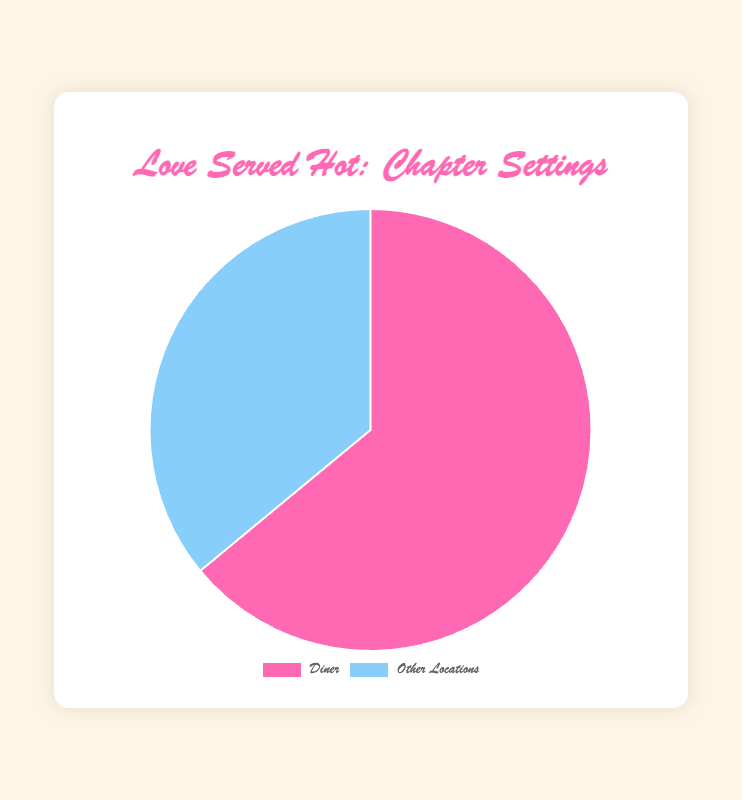what proportion of the story chapters are set in the diner? The pie chart shows 32 chapters in the diner out of a total of 50 chapters (32 + 18). Thus, the proportion is calculated as 32/50.
Answer: 64% how many more chapters are set in the diner compared to other locations? According to the pie chart, there are 32 chapters set in the diner and 18 in other locations. The difference is 32 - 18.
Answer: 14 what is the ratio of chapters set in the diner to chapters set in other locations? From the pie chart, the number of chapters set in the diner is 32, and the number set in other locations is 18. So, the ratio is 32:18. Simplified, it becomes 16:9.
Answer: 16:9 which location has more chapters set in it, and by how much? Comparing the two segments of the pie chart, the diner has 32 chapters, and other locations have 18 chapters. The diner has more chapters by the difference of 32 - 18.
Answer: diner, by 14 chapters if a chapter is chosen at random, what is the probability that it is set in the diner? There are 32 chapters set in the diner out of a total of 50 chapters (32 + 18). The probability is calculated as 32/50.
Answer: 0.64 how does the proportion of chapters set in the diner compare to those set in other locations? From the pie chart, we see the diner has 32 chapters and other locations have 18 chapters out of a total of 50 chapters. The proportion for diner is 32/50 (64%) and for other locations is 18/50 (36%).
Answer: 64% vs. 36% what is the visual difference in the pie chart sections representing the diner and other locations? The pie chart shows the section for the diner in pink and other locations in light blue. The pink section representing the diner is larger than the light blue section for other locations.
Answer: the diner section is larger and pink what fraction of the total chapters are set in other locations? The pie chart indicates that 18 chapters are set in other locations out of a total of 50 chapters. The fraction is calculated as 18/50.
Answer: 9/25 how does the size of the pink section compare to the light blue section in the pie chart? The pink section (diner) is visually larger than the light blue section (other locations), representing a greater proportion of chapters set in the diner.
Answer: the pink section is larger if 5 more chapters were added to the diner, what would be the new proportion? Adding 5 more chapters to the diner makes it 37 chapters. The total chapters would then be 55 (37 + 18). The new proportion for the diner is 37/55.
Answer: 67.27% 